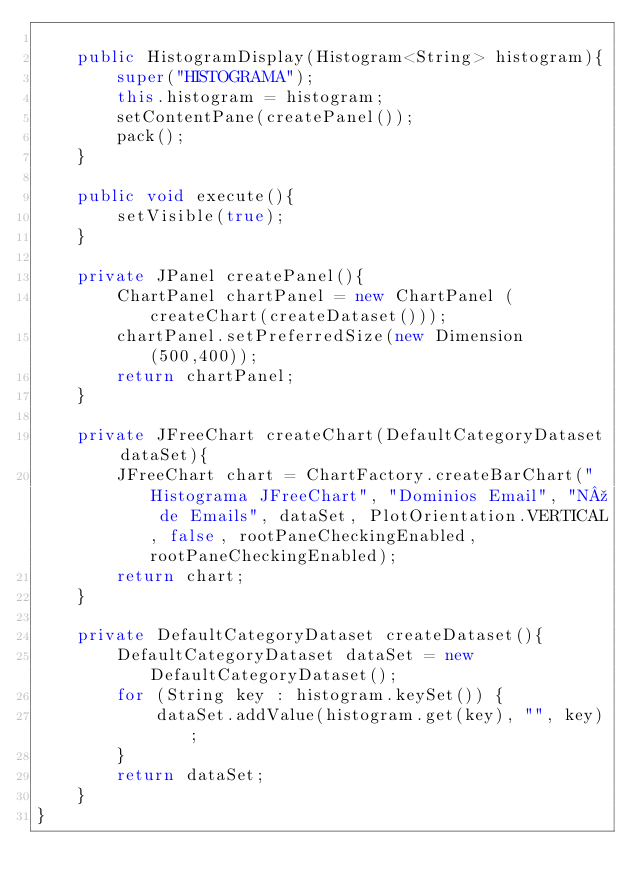Convert code to text. <code><loc_0><loc_0><loc_500><loc_500><_Java_>    
    public HistogramDisplay(Histogram<String> histogram){
        super("HISTOGRAMA");
        this.histogram = histogram;
        setContentPane(createPanel());
        pack();
    }
    
    public void execute(){
        setVisible(true);
    }
    
    private JPanel createPanel(){
        ChartPanel chartPanel = new ChartPanel (createChart(createDataset()));
        chartPanel.setPreferredSize(new Dimension (500,400));
        return chartPanel;
    }
    
    private JFreeChart createChart(DefaultCategoryDataset dataSet){
        JFreeChart chart = ChartFactory.createBarChart("Histograma JFreeChart", "Dominios Email", "Nº de Emails", dataSet, PlotOrientation.VERTICAL, false, rootPaneCheckingEnabled, rootPaneCheckingEnabled);
        return chart;
    }
    
    private DefaultCategoryDataset createDataset(){
        DefaultCategoryDataset dataSet = new DefaultCategoryDataset();
        for (String key : histogram.keySet()) {
            dataSet.addValue(histogram.get(key), "", key);
        }
        return dataSet;
    }
}
</code> 